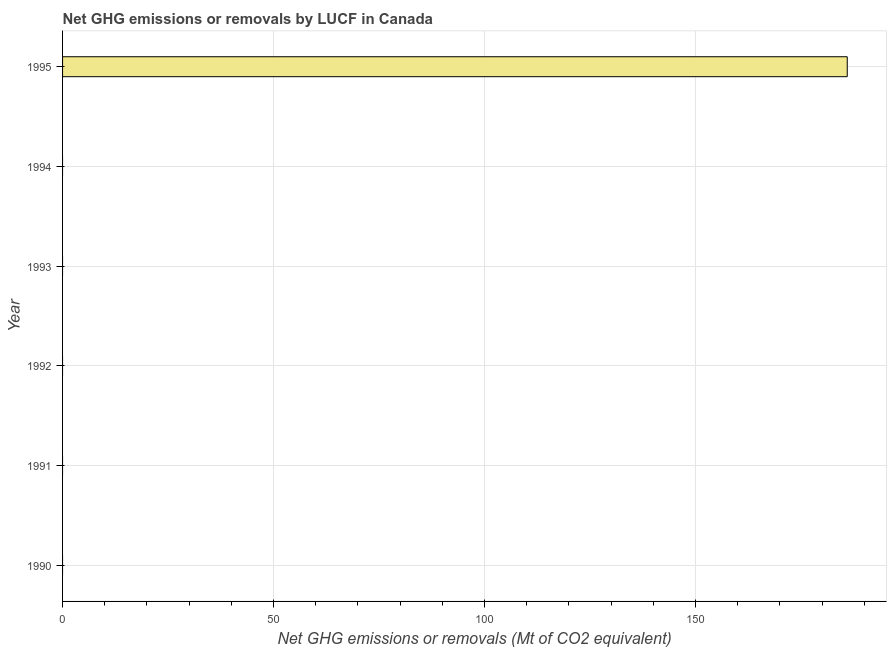Does the graph contain any zero values?
Provide a short and direct response. Yes. What is the title of the graph?
Your answer should be very brief. Net GHG emissions or removals by LUCF in Canada. What is the label or title of the X-axis?
Your answer should be compact. Net GHG emissions or removals (Mt of CO2 equivalent). What is the label or title of the Y-axis?
Give a very brief answer. Year. What is the ghg net emissions or removals in 1995?
Ensure brevity in your answer.  185.97. Across all years, what is the maximum ghg net emissions or removals?
Your answer should be very brief. 185.97. In which year was the ghg net emissions or removals maximum?
Your answer should be compact. 1995. What is the sum of the ghg net emissions or removals?
Your answer should be very brief. 185.97. What is the average ghg net emissions or removals per year?
Your answer should be compact. 31. What is the median ghg net emissions or removals?
Provide a short and direct response. 0. In how many years, is the ghg net emissions or removals greater than 90 Mt?
Your answer should be compact. 1. What is the difference between the highest and the lowest ghg net emissions or removals?
Give a very brief answer. 185.97. In how many years, is the ghg net emissions or removals greater than the average ghg net emissions or removals taken over all years?
Make the answer very short. 1. How many bars are there?
Keep it short and to the point. 1. Are all the bars in the graph horizontal?
Offer a terse response. Yes. Are the values on the major ticks of X-axis written in scientific E-notation?
Ensure brevity in your answer.  No. What is the Net GHG emissions or removals (Mt of CO2 equivalent) in 1991?
Your response must be concise. 0. What is the Net GHG emissions or removals (Mt of CO2 equivalent) in 1995?
Your response must be concise. 185.97. 